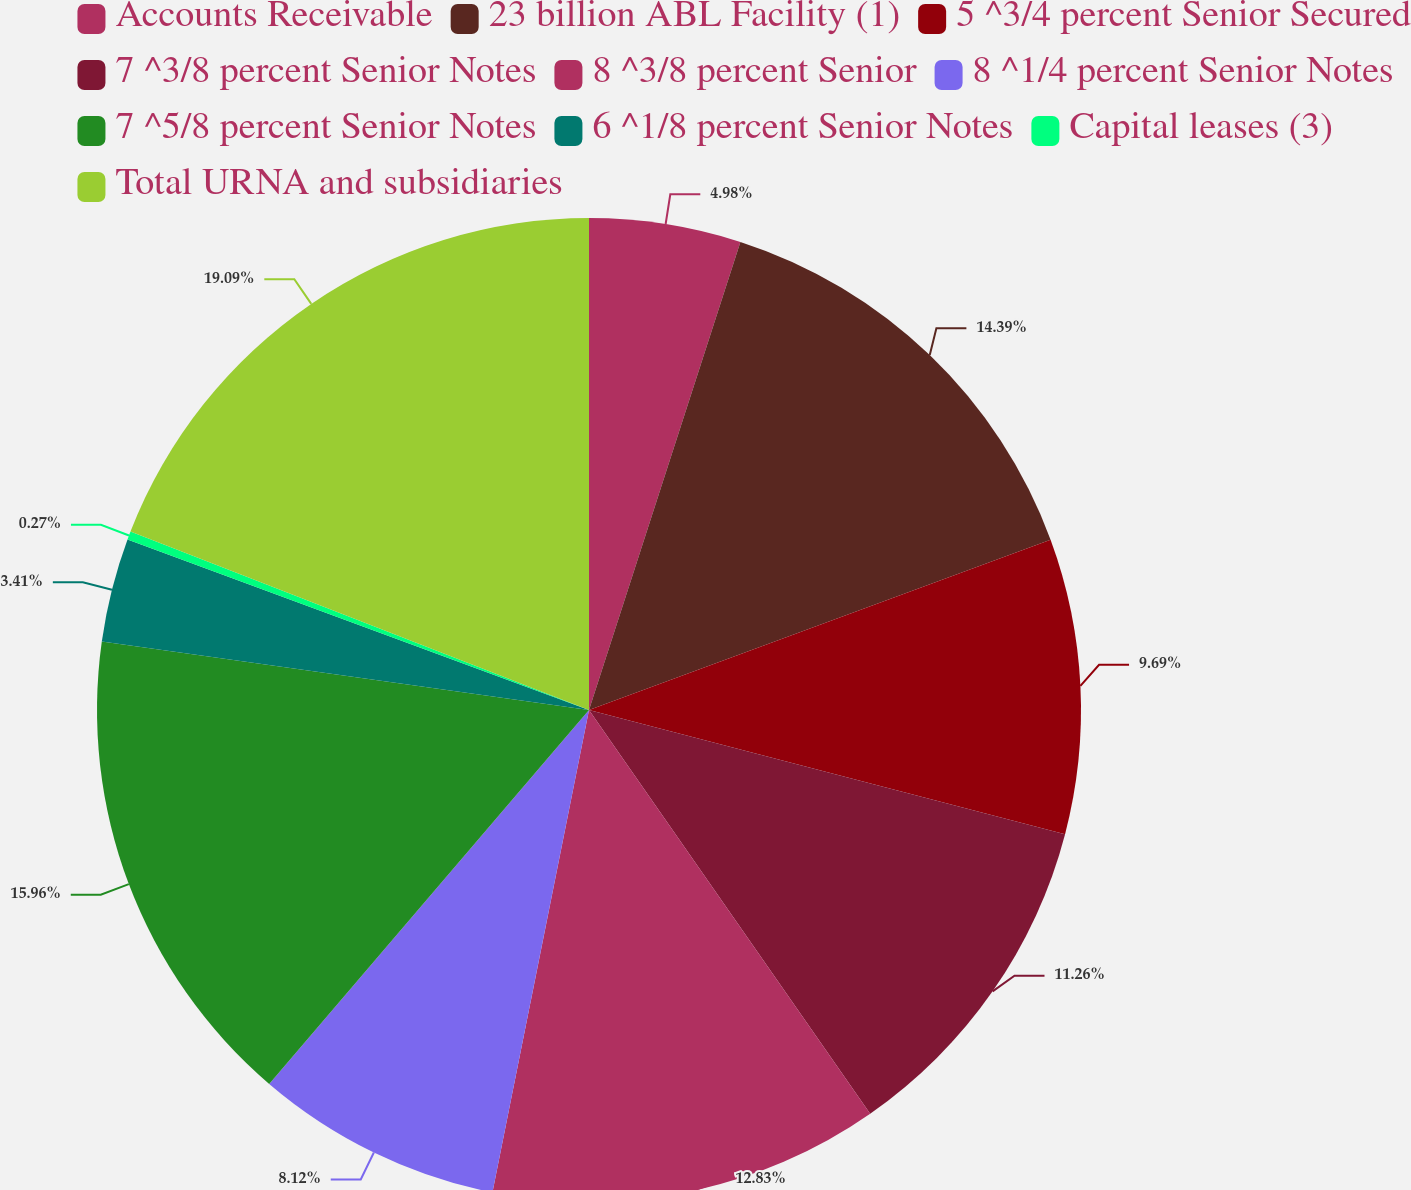Convert chart to OTSL. <chart><loc_0><loc_0><loc_500><loc_500><pie_chart><fcel>Accounts Receivable<fcel>23 billion ABL Facility (1)<fcel>5 ^3/4 percent Senior Secured<fcel>7 ^3/8 percent Senior Notes<fcel>8 ^3/8 percent Senior<fcel>8 ^1/4 percent Senior Notes<fcel>7 ^5/8 percent Senior Notes<fcel>6 ^1/8 percent Senior Notes<fcel>Capital leases (3)<fcel>Total URNA and subsidiaries<nl><fcel>4.98%<fcel>14.4%<fcel>9.69%<fcel>11.26%<fcel>12.83%<fcel>8.12%<fcel>15.97%<fcel>3.41%<fcel>0.27%<fcel>19.1%<nl></chart> 